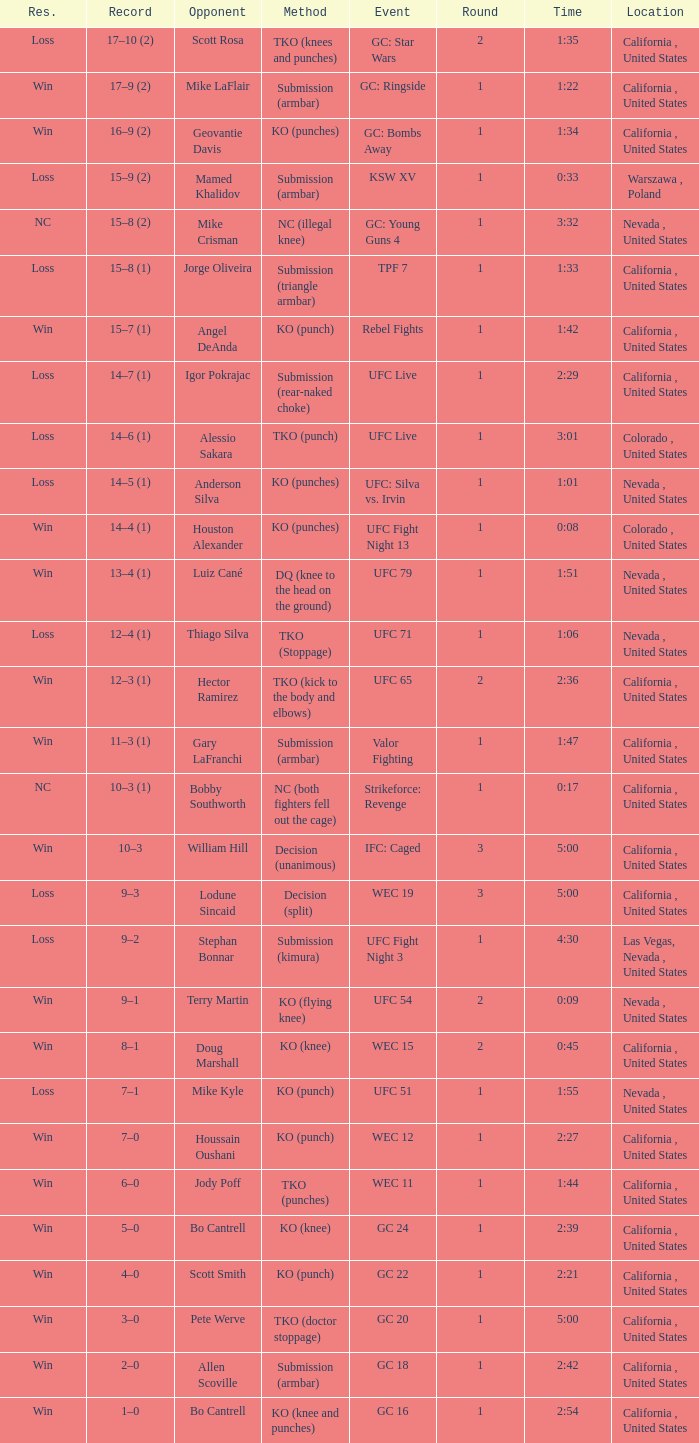What was the approach when the time was 1:01? KO (punches). 